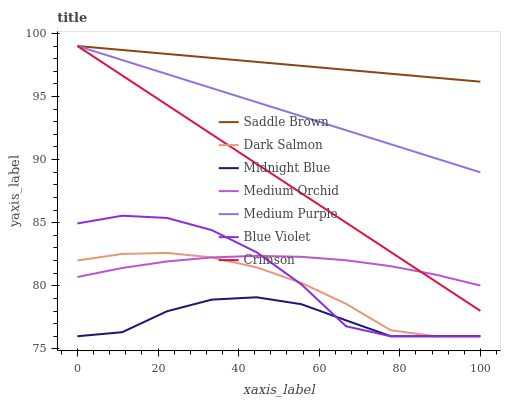Does Midnight Blue have the minimum area under the curve?
Answer yes or no. Yes. Does Saddle Brown have the maximum area under the curve?
Answer yes or no. Yes. Does Medium Orchid have the minimum area under the curve?
Answer yes or no. No. Does Medium Orchid have the maximum area under the curve?
Answer yes or no. No. Is Medium Purple the smoothest?
Answer yes or no. Yes. Is Blue Violet the roughest?
Answer yes or no. Yes. Is Medium Orchid the smoothest?
Answer yes or no. No. Is Medium Orchid the roughest?
Answer yes or no. No. Does Midnight Blue have the lowest value?
Answer yes or no. Yes. Does Medium Orchid have the lowest value?
Answer yes or no. No. Does Saddle Brown have the highest value?
Answer yes or no. Yes. Does Medium Orchid have the highest value?
Answer yes or no. No. Is Dark Salmon less than Saddle Brown?
Answer yes or no. Yes. Is Crimson greater than Dark Salmon?
Answer yes or no. Yes. Does Saddle Brown intersect Medium Purple?
Answer yes or no. Yes. Is Saddle Brown less than Medium Purple?
Answer yes or no. No. Is Saddle Brown greater than Medium Purple?
Answer yes or no. No. Does Dark Salmon intersect Saddle Brown?
Answer yes or no. No. 